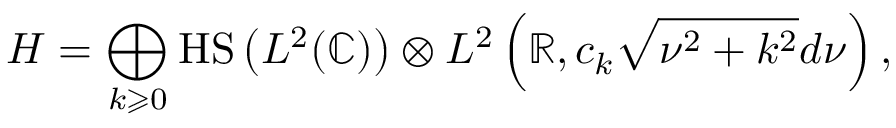<formula> <loc_0><loc_0><loc_500><loc_500>H = \bigoplus _ { k \geqslant 0 } { H S } \left ( L ^ { 2 } ( \mathbb { C } ) \right ) \otimes L ^ { 2 } \left ( \mathbb { R } , c _ { k } { \sqrt { \nu ^ { 2 } + k ^ { 2 } } } d \nu \right ) ,</formula> 